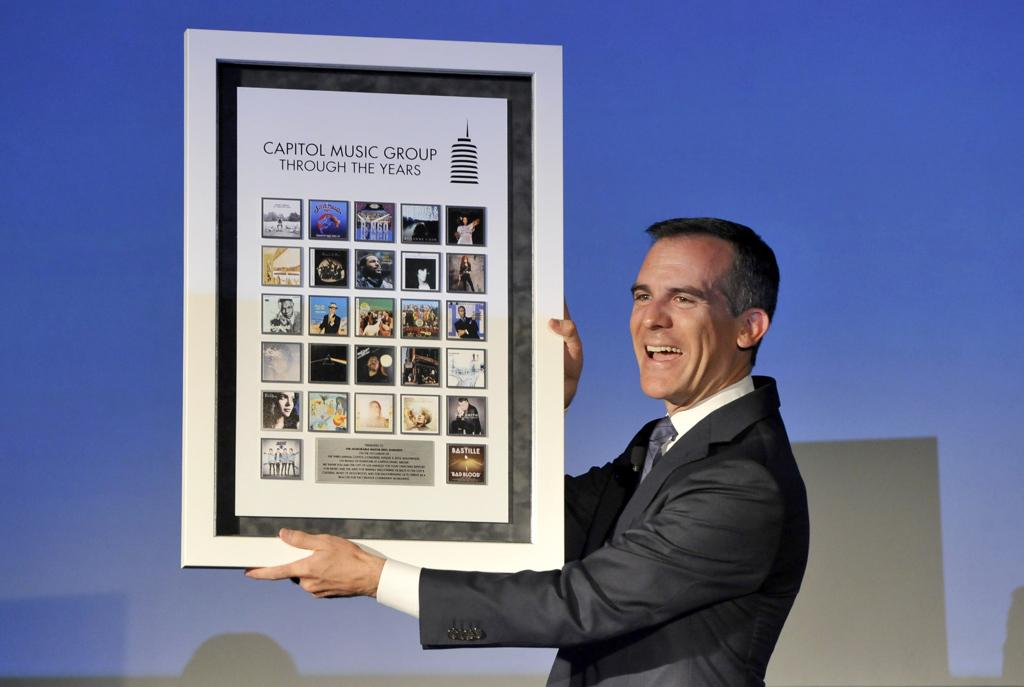<image>
Describe the image concisely. A man holding up a collection of photos for the capitol music group through the years. 